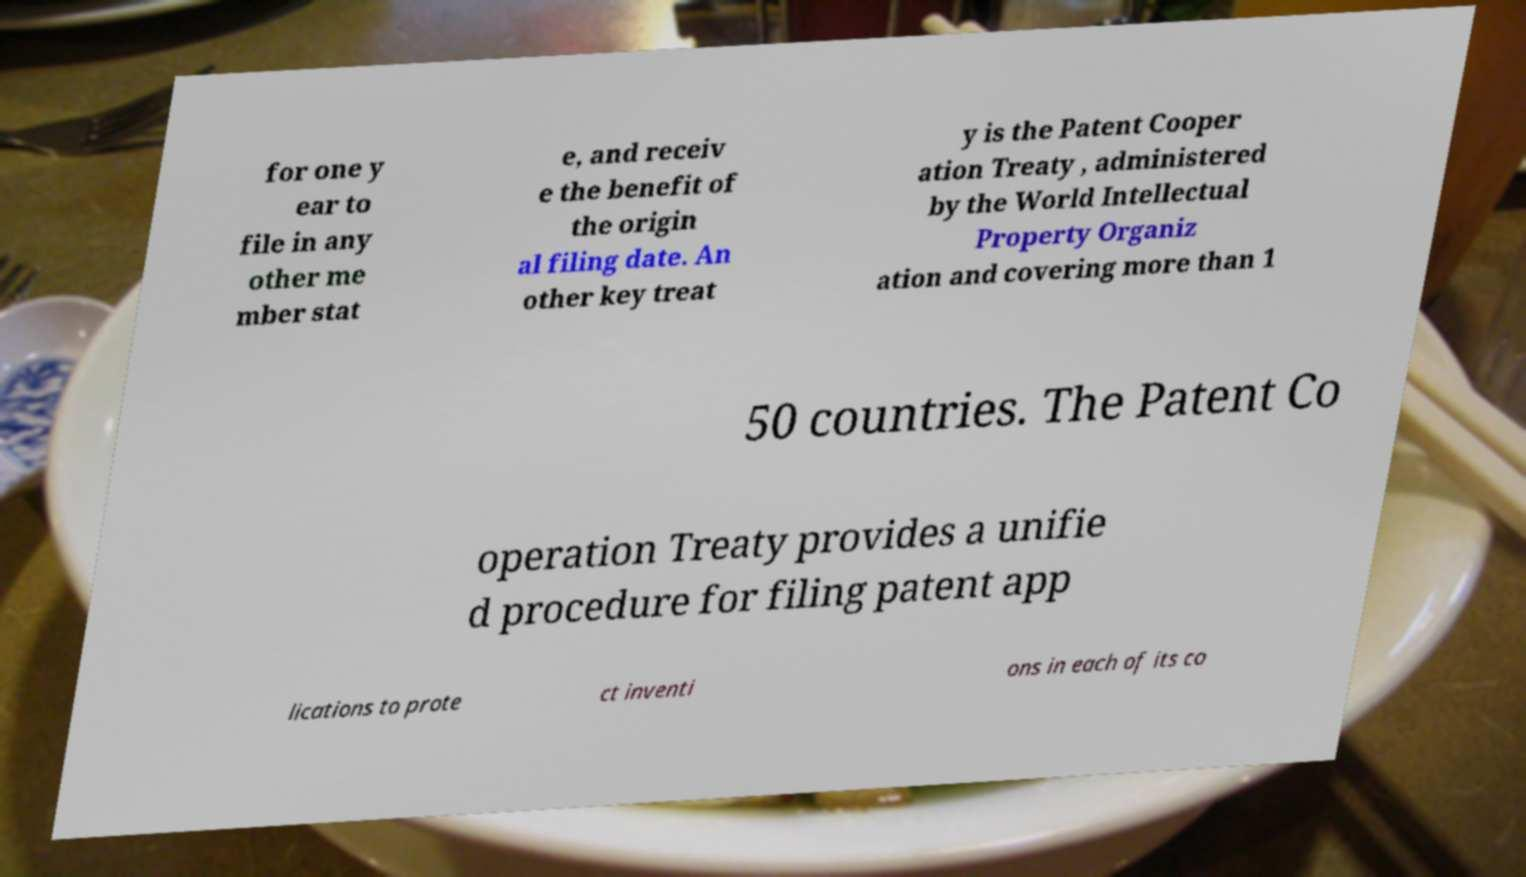Could you assist in decoding the text presented in this image and type it out clearly? for one y ear to file in any other me mber stat e, and receiv e the benefit of the origin al filing date. An other key treat y is the Patent Cooper ation Treaty , administered by the World Intellectual Property Organiz ation and covering more than 1 50 countries. The Patent Co operation Treaty provides a unifie d procedure for filing patent app lications to prote ct inventi ons in each of its co 